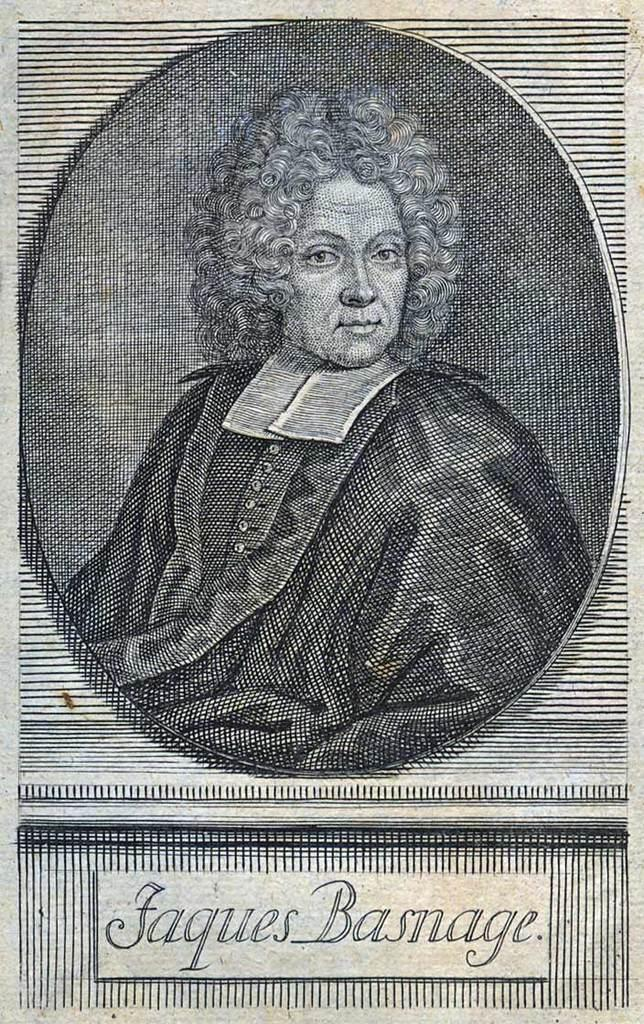What is featured in the image? There is a poster in the image. What is shown on the poster? A man is depicted on the poster. What is the man wearing in the poster? The man is wearing a black dress. Is there any text on the poster? Yes, there is a person's name at the bottom of the poster. What type of disease is the man fighting against in the image? There is no indication of a disease or fighting in the image; it features a man wearing a black dress on a poster with a person's name at the bottom. 